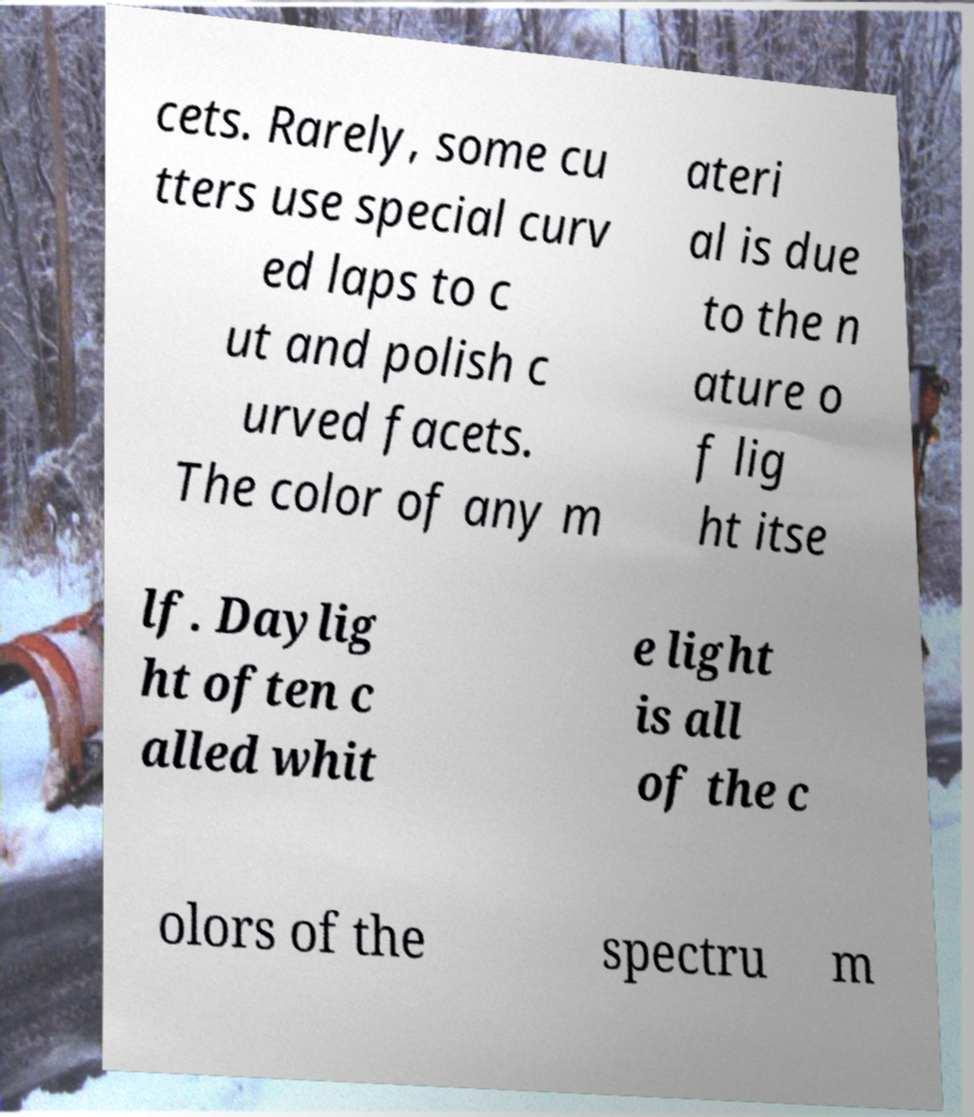Please identify and transcribe the text found in this image. cets. Rarely, some cu tters use special curv ed laps to c ut and polish c urved facets. The color of any m ateri al is due to the n ature o f lig ht itse lf. Daylig ht often c alled whit e light is all of the c olors of the spectru m 